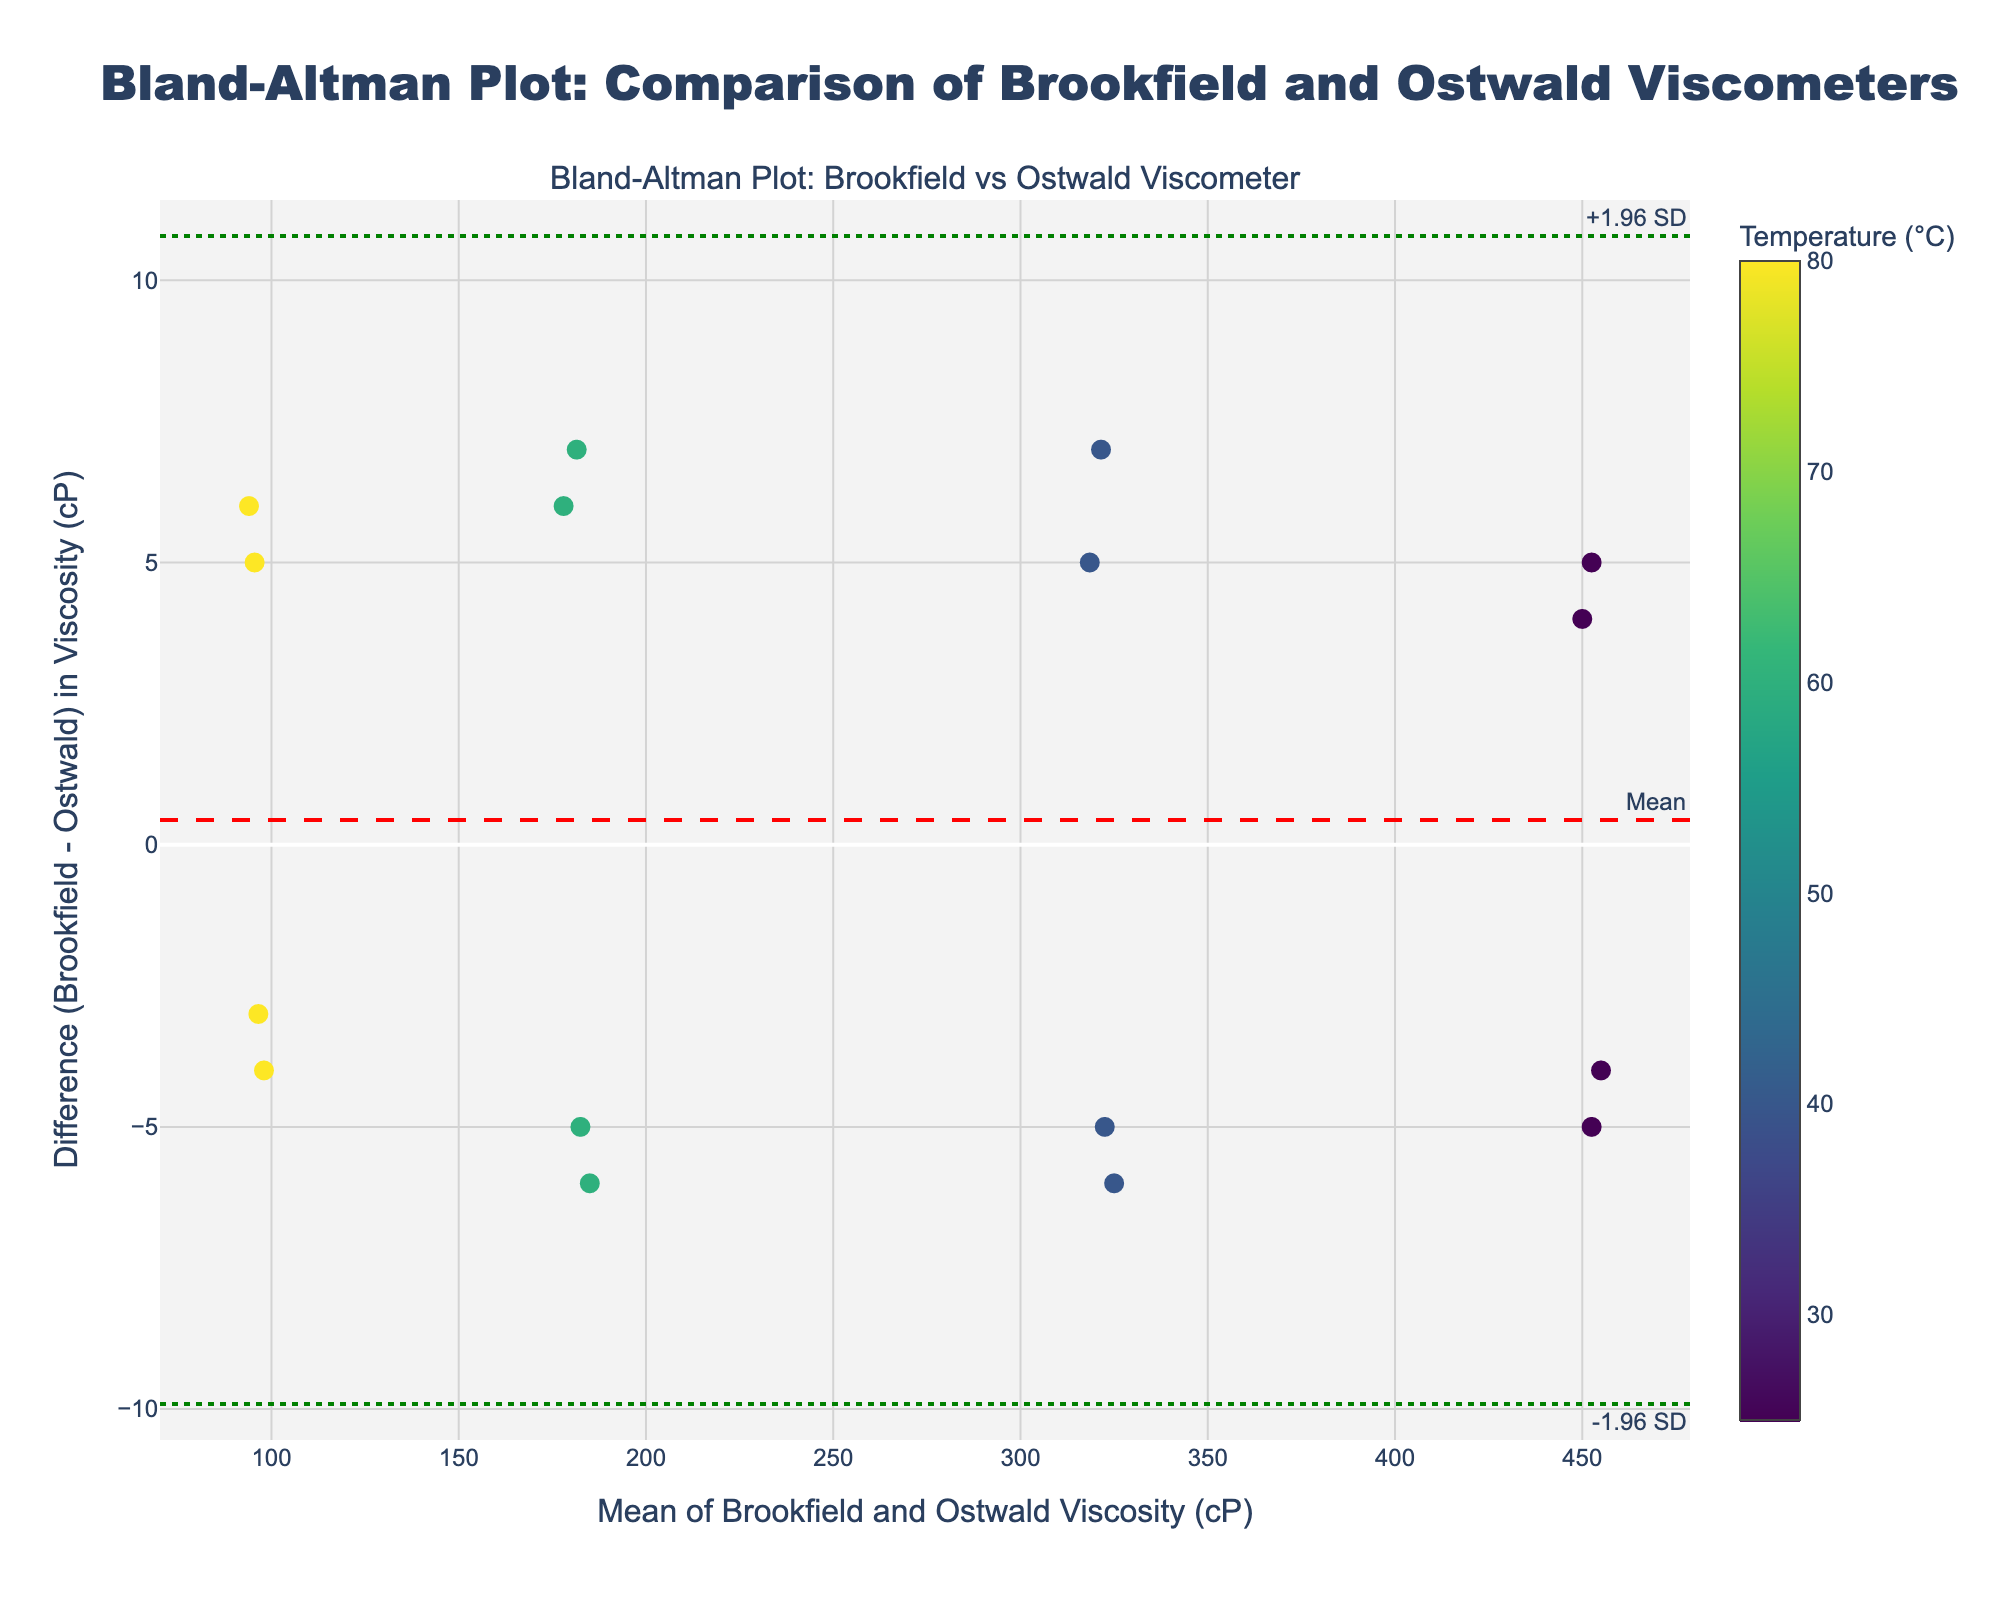How many data points are shown on the plot? By counting the individual markers on the plot, each representing a data point, you can determine the total number.
Answer: 16 What is the title of the Bland-Altman plot? The title of the plot is usually displayed at the top of the figure. In this case, read the title directly from the plot.
Answer: Bland-Altman Plot: Comparison of Brookfield and Ostwald Viscometers Which method has the highest mean viscosity at 25°C? Hover over or refer to the legend and dots on the plot to find the markers corresponding to 25°C and compare their "Method" values, focusing on the mean viscosity values.
Answer: Falling Ball What is the overall trend of the difference in viscosity measurements as the mean viscosity increases? Observe the distribution of the points along the y-axis (difference) as the x-axis (mean viscosity) values increase to identify any trends or patterns.
Answer: The differences remain relatively small and stable, with no clear increasing or decreasing trend What are the values of the limits of agreement? The values of the limits of agreement are typically represented by the dotted lines and can be identified through the annotations on the plot.
Answer: Approximately +10 cP and -10 cP What's the difference in viscosity (cP) for the Cone and Plate method at 80°C? Hover over or refer to the data point for the Cone and Plate method at 80°C to find the difference in viscosity, represented on the y-axis.
Answer: -6 cP Which temperature range shows the largest variability in viscosity differences? By observing the color-coded markers, determine the range where the differences in viscosity values vary the most. Look for a wide spread along the y-axis at specific temperature colors.
Answer: 40°C Is there any method that consistently shows lower viscosities using Ostwald compared to Brookfield, and at which temperatures? Compare the differences for each method and note if the differences are negative more frequently, indicating lower viscosities using Ostwald.
Answer: Capillary, at all temperatures What is the mean difference in viscosity measurements between the Brookfield and Ostwald viscometers? The mean difference is represented by the solid red line on the plot. Look for the annotation next to this line.
Answer: 0 cP How does the Brookfield viscosity at 60°C compare to the Ostwald viscosity for the Rotational method? Locate the data points for the Rotational method at 60°C and check their positions on the mean vs. difference plot to determine how they compare.
Answer: Brookfield viscosity is 5 cP higher than Ostwald 